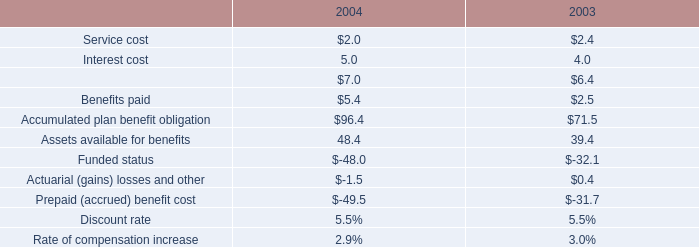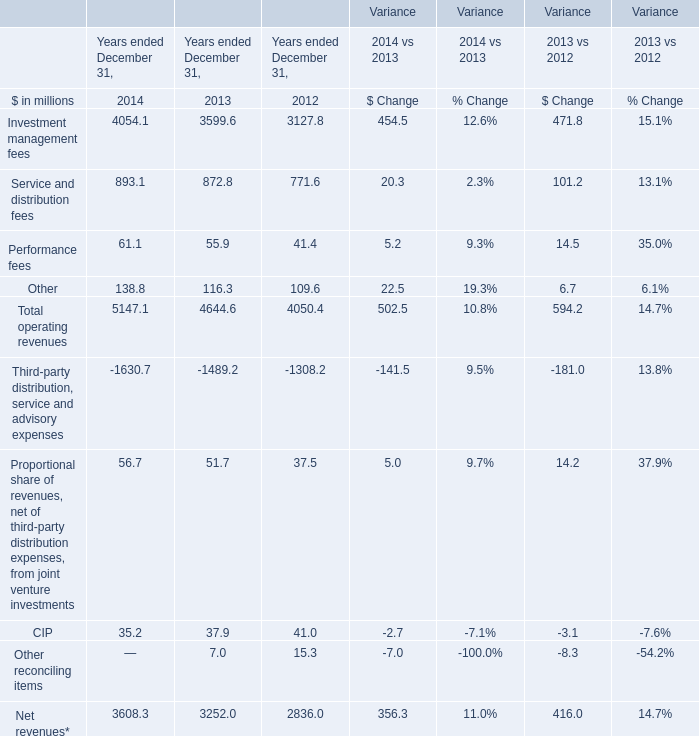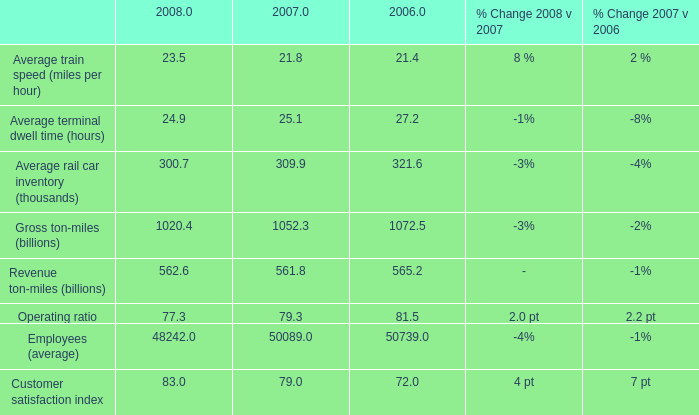If Total operating revenues develops with the same growth rate in 2013, what will it reach in 2014? (in million) 
Computations: (4644.6 * (1 + ((4644.6 - 4050.4) / 4050.4)))
Answer: 5325.97007. 